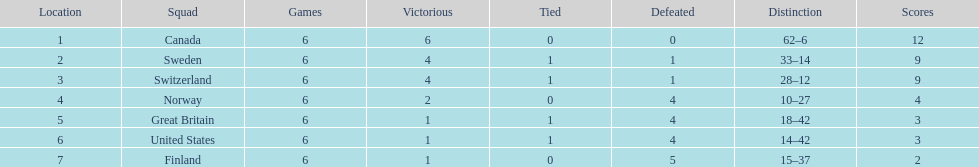In which nation did the united states rank higher than? Finland. 